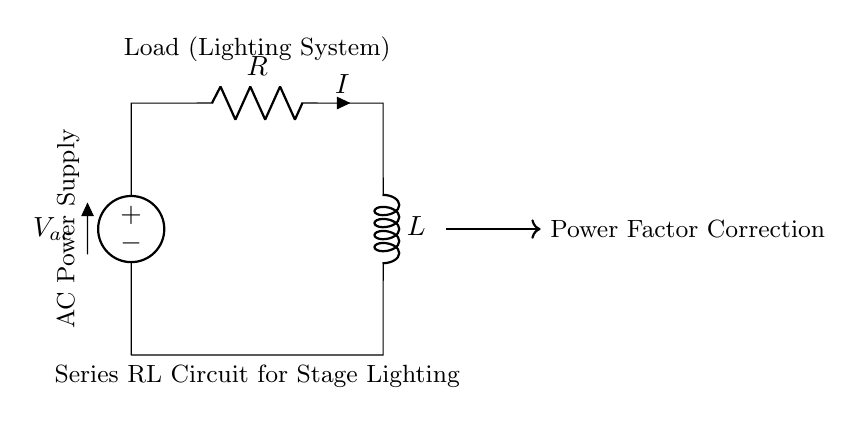What type of circuit is shown? The circuit diagram depicts a series RL circuit, which consists of a resistor and an inductor connected in series. This is indicated by the labeling of the components within the diagram.
Answer: Series RL circuit What is the load in this circuit? The diagram specifies that the load is a lighting system, which is labeled above the circuit. This informs us that the circuit is used to provide power to stage lighting.
Answer: Lighting system What component type is labeled as 'R'? The component labeled 'R' in the circuit diagram represents a resistor, which is a standard component that impedes the flow of electric current. The label and the symbol indicate this directly.
Answer: Resistor What is the purpose of this circuit? This circuit is identified as being for power factor correction, which aims to improve the power factor of the load, typically for more efficient energy consumption in lighting systems. This purpose is indicated in the diagram.
Answer: Power Factor Correction How does increasing the inductance affect the current? Increasing the inductance in a series RL circuit will decrease the current for a given RMS voltage due to the higher opposition to current flow (impedance). This is derived from the relationship between inductance, frequency, and reactance in the circuit.
Answer: Decreases current What does the arrow indicate in the circuit diagram? The thick arrow pointing towards the text "Power Factor Correction" indicates the direction of power factor correction in the circuit. It visually emphasizes the function of the circuit as related to improving the efficiency of power use.
Answer: Power factor correction process 